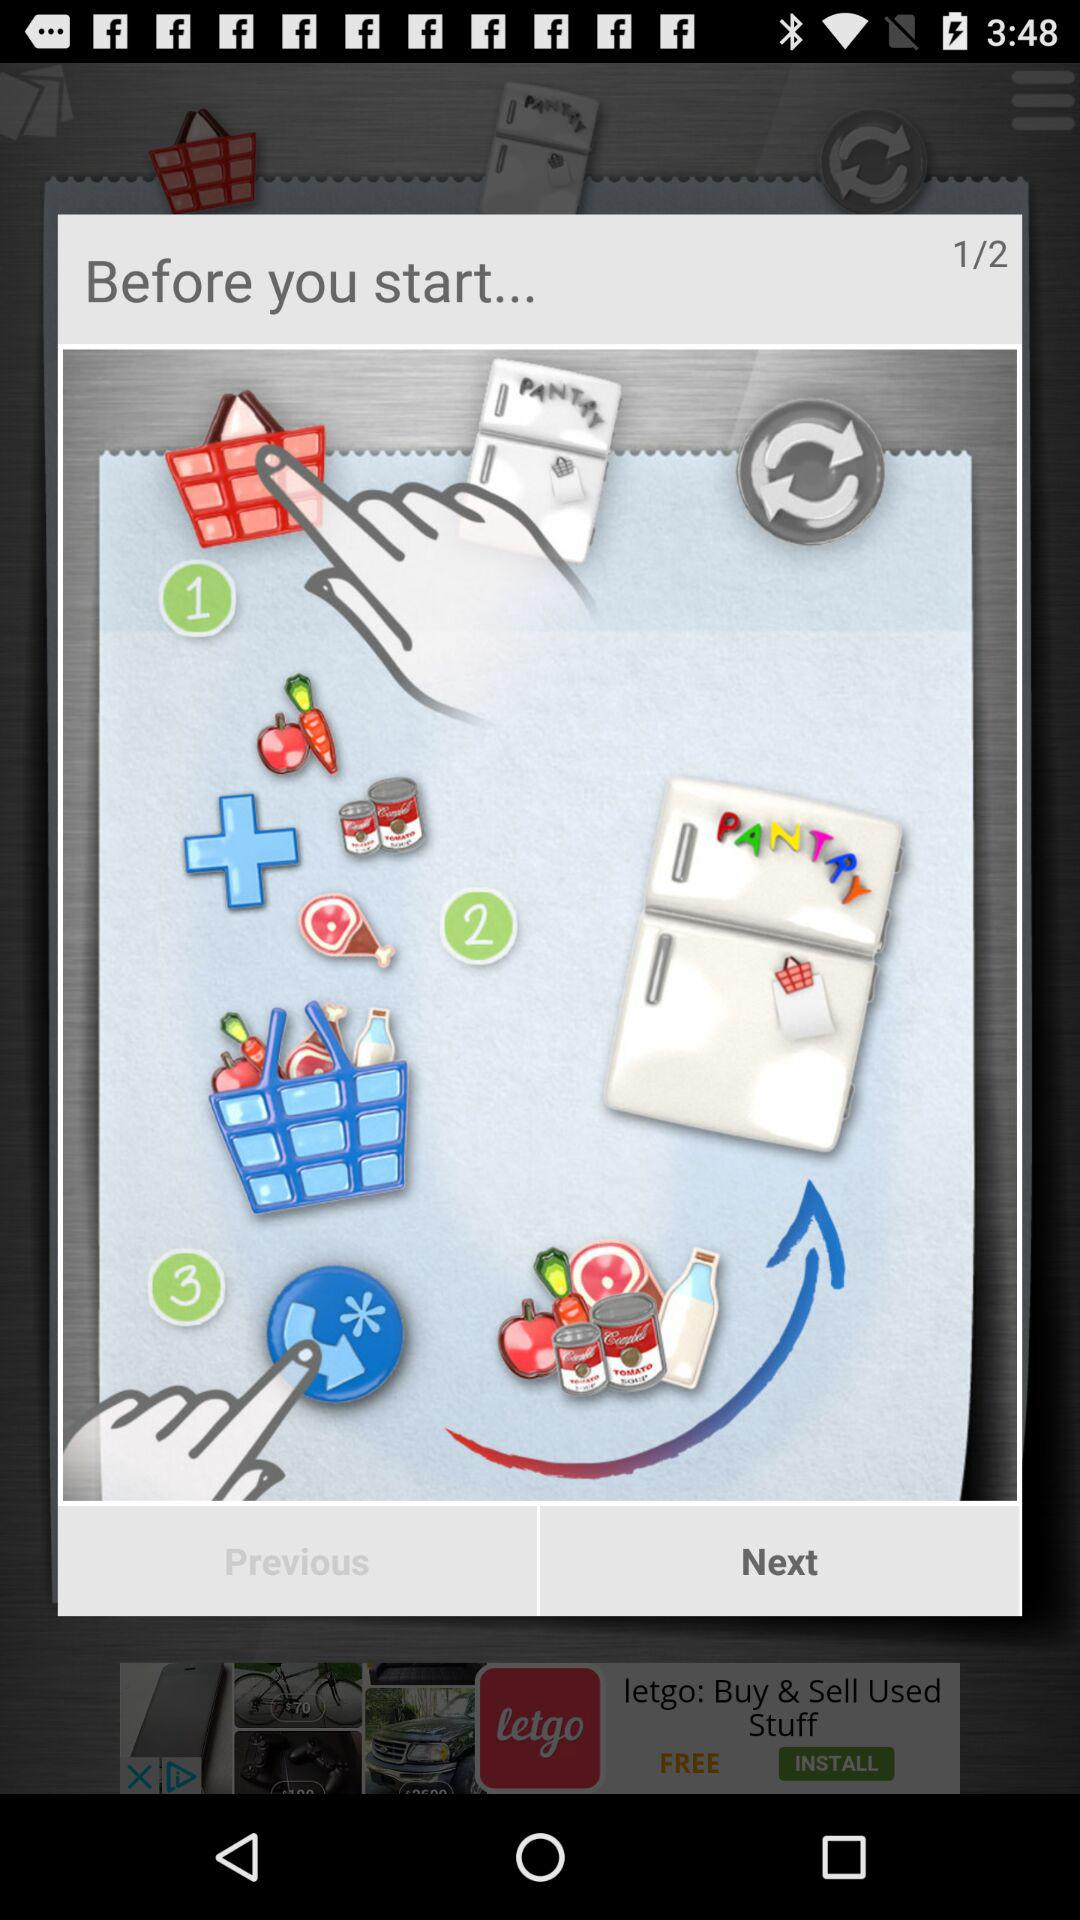How many green circles are there with a number that is not 1?
Answer the question using a single word or phrase. 2 